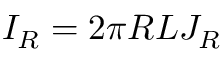<formula> <loc_0><loc_0><loc_500><loc_500>I _ { R } = 2 \pi R L J _ { R }</formula> 